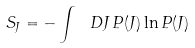<formula> <loc_0><loc_0><loc_500><loc_500>S _ { J } = - \int \ D J \, P ( J ) \ln P ( J )</formula> 